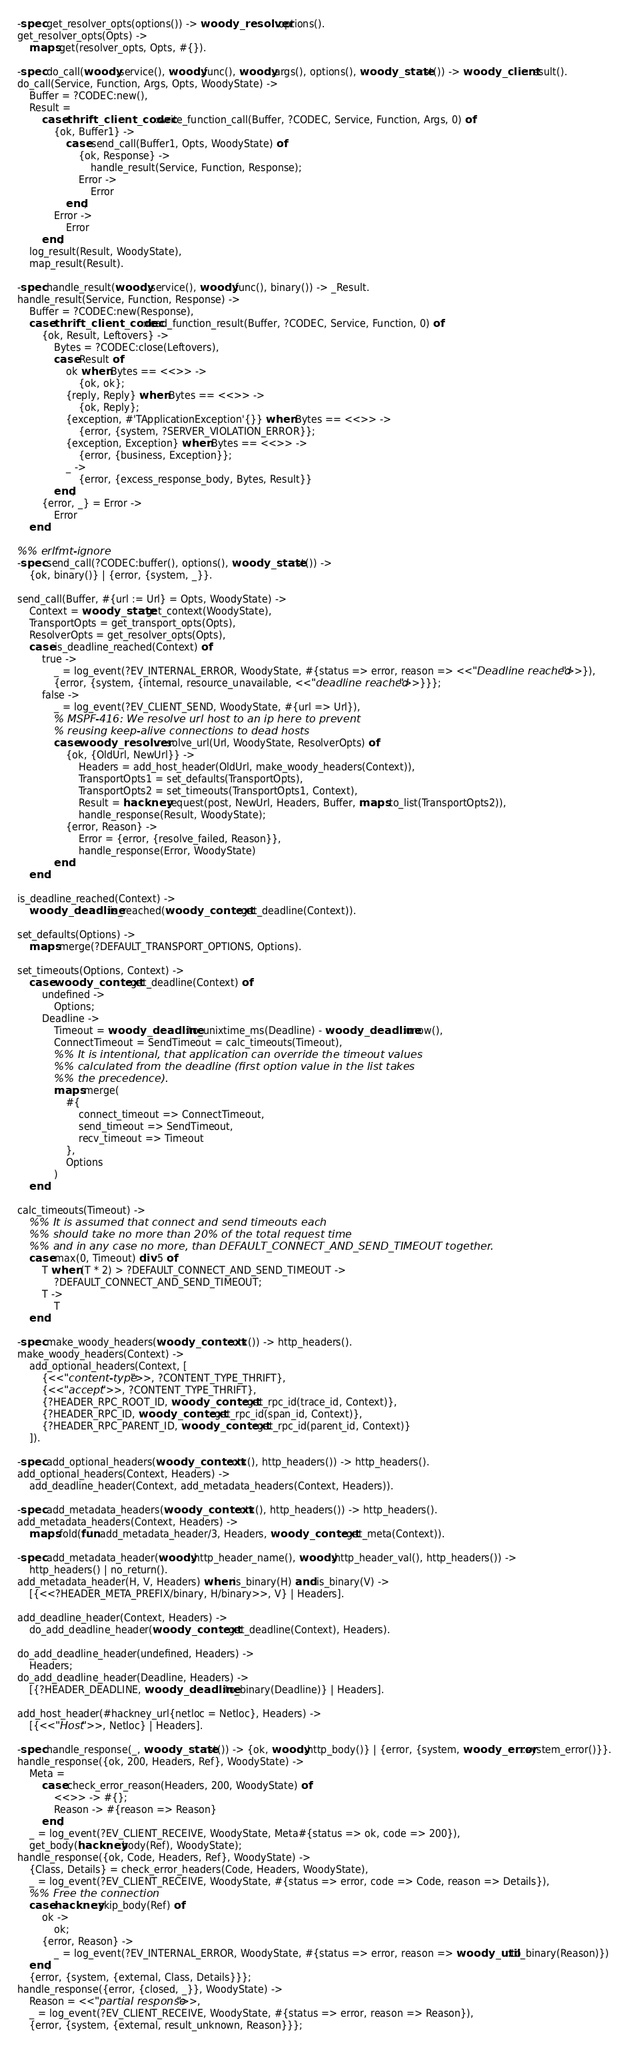Convert code to text. <code><loc_0><loc_0><loc_500><loc_500><_Erlang_>-spec get_resolver_opts(options()) -> woody_resolver:options().
get_resolver_opts(Opts) ->
    maps:get(resolver_opts, Opts, #{}).

-spec do_call(woody:service(), woody:func(), woody:args(), options(), woody_state:st()) -> woody_client:result().
do_call(Service, Function, Args, Opts, WoodyState) ->
    Buffer = ?CODEC:new(),
    Result =
        case thrift_client_codec:write_function_call(Buffer, ?CODEC, Service, Function, Args, 0) of
            {ok, Buffer1} ->
                case send_call(Buffer1, Opts, WoodyState) of
                    {ok, Response} ->
                        handle_result(Service, Function, Response);
                    Error ->
                        Error
                end;
            Error ->
                Error
        end,
    log_result(Result, WoodyState),
    map_result(Result).

-spec handle_result(woody:service(), woody:func(), binary()) -> _Result.
handle_result(Service, Function, Response) ->
    Buffer = ?CODEC:new(Response),
    case thrift_client_codec:read_function_result(Buffer, ?CODEC, Service, Function, 0) of
        {ok, Result, Leftovers} ->
            Bytes = ?CODEC:close(Leftovers),
            case Result of
                ok when Bytes == <<>> ->
                    {ok, ok};
                {reply, Reply} when Bytes == <<>> ->
                    {ok, Reply};
                {exception, #'TApplicationException'{}} when Bytes == <<>> ->
                    {error, {system, ?SERVER_VIOLATION_ERROR}};
                {exception, Exception} when Bytes == <<>> ->
                    {error, {business, Exception}};
                _ ->
                    {error, {excess_response_body, Bytes, Result}}
            end;
        {error, _} = Error ->
            Error
    end.

%% erlfmt-ignore
-spec send_call(?CODEC:buffer(), options(), woody_state:st()) ->
    {ok, binary()} | {error, {system, _}}.

send_call(Buffer, #{url := Url} = Opts, WoodyState) ->
    Context = woody_state:get_context(WoodyState),
    TransportOpts = get_transport_opts(Opts),
    ResolverOpts = get_resolver_opts(Opts),
    case is_deadline_reached(Context) of
        true ->
            _ = log_event(?EV_INTERNAL_ERROR, WoodyState, #{status => error, reason => <<"Deadline reached">>}),
            {error, {system, {internal, resource_unavailable, <<"deadline reached">>}}};
        false ->
            _ = log_event(?EV_CLIENT_SEND, WoodyState, #{url => Url}),
            % MSPF-416: We resolve url host to an ip here to prevent
            % reusing keep-alive connections to dead hosts
            case woody_resolver:resolve_url(Url, WoodyState, ResolverOpts) of
                {ok, {OldUrl, NewUrl}} ->
                    Headers = add_host_header(OldUrl, make_woody_headers(Context)),
                    TransportOpts1 = set_defaults(TransportOpts),
                    TransportOpts2 = set_timeouts(TransportOpts1, Context),
                    Result = hackney:request(post, NewUrl, Headers, Buffer, maps:to_list(TransportOpts2)),
                    handle_response(Result, WoodyState);
                {error, Reason} ->
                    Error = {error, {resolve_failed, Reason}},
                    handle_response(Error, WoodyState)
            end
    end.

is_deadline_reached(Context) ->
    woody_deadline:is_reached(woody_context:get_deadline(Context)).

set_defaults(Options) ->
    maps:merge(?DEFAULT_TRANSPORT_OPTIONS, Options).

set_timeouts(Options, Context) ->
    case woody_context:get_deadline(Context) of
        undefined ->
            Options;
        Deadline ->
            Timeout = woody_deadline:to_unixtime_ms(Deadline) - woody_deadline:unow(),
            ConnectTimeout = SendTimeout = calc_timeouts(Timeout),
            %% It is intentional, that application can override the timeout values
            %% calculated from the deadline (first option value in the list takes
            %% the precedence).
            maps:merge(
                #{
                    connect_timeout => ConnectTimeout,
                    send_timeout => SendTimeout,
                    recv_timeout => Timeout
                },
                Options
            )
    end.

calc_timeouts(Timeout) ->
    %% It is assumed that connect and send timeouts each
    %% should take no more than 20% of the total request time
    %% and in any case no more, than DEFAULT_CONNECT_AND_SEND_TIMEOUT together.
    case max(0, Timeout) div 5 of
        T when (T * 2) > ?DEFAULT_CONNECT_AND_SEND_TIMEOUT ->
            ?DEFAULT_CONNECT_AND_SEND_TIMEOUT;
        T ->
            T
    end.

-spec make_woody_headers(woody_context:ctx()) -> http_headers().
make_woody_headers(Context) ->
    add_optional_headers(Context, [
        {<<"content-type">>, ?CONTENT_TYPE_THRIFT},
        {<<"accept">>, ?CONTENT_TYPE_THRIFT},
        {?HEADER_RPC_ROOT_ID, woody_context:get_rpc_id(trace_id, Context)},
        {?HEADER_RPC_ID, woody_context:get_rpc_id(span_id, Context)},
        {?HEADER_RPC_PARENT_ID, woody_context:get_rpc_id(parent_id, Context)}
    ]).

-spec add_optional_headers(woody_context:ctx(), http_headers()) -> http_headers().
add_optional_headers(Context, Headers) ->
    add_deadline_header(Context, add_metadata_headers(Context, Headers)).

-spec add_metadata_headers(woody_context:ctx(), http_headers()) -> http_headers().
add_metadata_headers(Context, Headers) ->
    maps:fold(fun add_metadata_header/3, Headers, woody_context:get_meta(Context)).

-spec add_metadata_header(woody:http_header_name(), woody:http_header_val(), http_headers()) ->
    http_headers() | no_return().
add_metadata_header(H, V, Headers) when is_binary(H) and is_binary(V) ->
    [{<<?HEADER_META_PREFIX/binary, H/binary>>, V} | Headers].

add_deadline_header(Context, Headers) ->
    do_add_deadline_header(woody_context:get_deadline(Context), Headers).

do_add_deadline_header(undefined, Headers) ->
    Headers;
do_add_deadline_header(Deadline, Headers) ->
    [{?HEADER_DEADLINE, woody_deadline:to_binary(Deadline)} | Headers].

add_host_header(#hackney_url{netloc = Netloc}, Headers) ->
    [{<<"Host">>, Netloc} | Headers].

-spec handle_response(_, woody_state:st()) -> {ok, woody:http_body()} | {error, {system, woody_error:system_error()}}.
handle_response({ok, 200, Headers, Ref}, WoodyState) ->
    Meta =
        case check_error_reason(Headers, 200, WoodyState) of
            <<>> -> #{};
            Reason -> #{reason => Reason}
        end,
    _ = log_event(?EV_CLIENT_RECEIVE, WoodyState, Meta#{status => ok, code => 200}),
    get_body(hackney:body(Ref), WoodyState);
handle_response({ok, Code, Headers, Ref}, WoodyState) ->
    {Class, Details} = check_error_headers(Code, Headers, WoodyState),
    _ = log_event(?EV_CLIENT_RECEIVE, WoodyState, #{status => error, code => Code, reason => Details}),
    %% Free the connection
    case hackney:skip_body(Ref) of
        ok ->
            ok;
        {error, Reason} ->
            _ = log_event(?EV_INTERNAL_ERROR, WoodyState, #{status => error, reason => woody_util:to_binary(Reason)})
    end,
    {error, {system, {external, Class, Details}}};
handle_response({error, {closed, _}}, WoodyState) ->
    Reason = <<"partial response">>,
    _ = log_event(?EV_CLIENT_RECEIVE, WoodyState, #{status => error, reason => Reason}),
    {error, {system, {external, result_unknown, Reason}}};</code> 